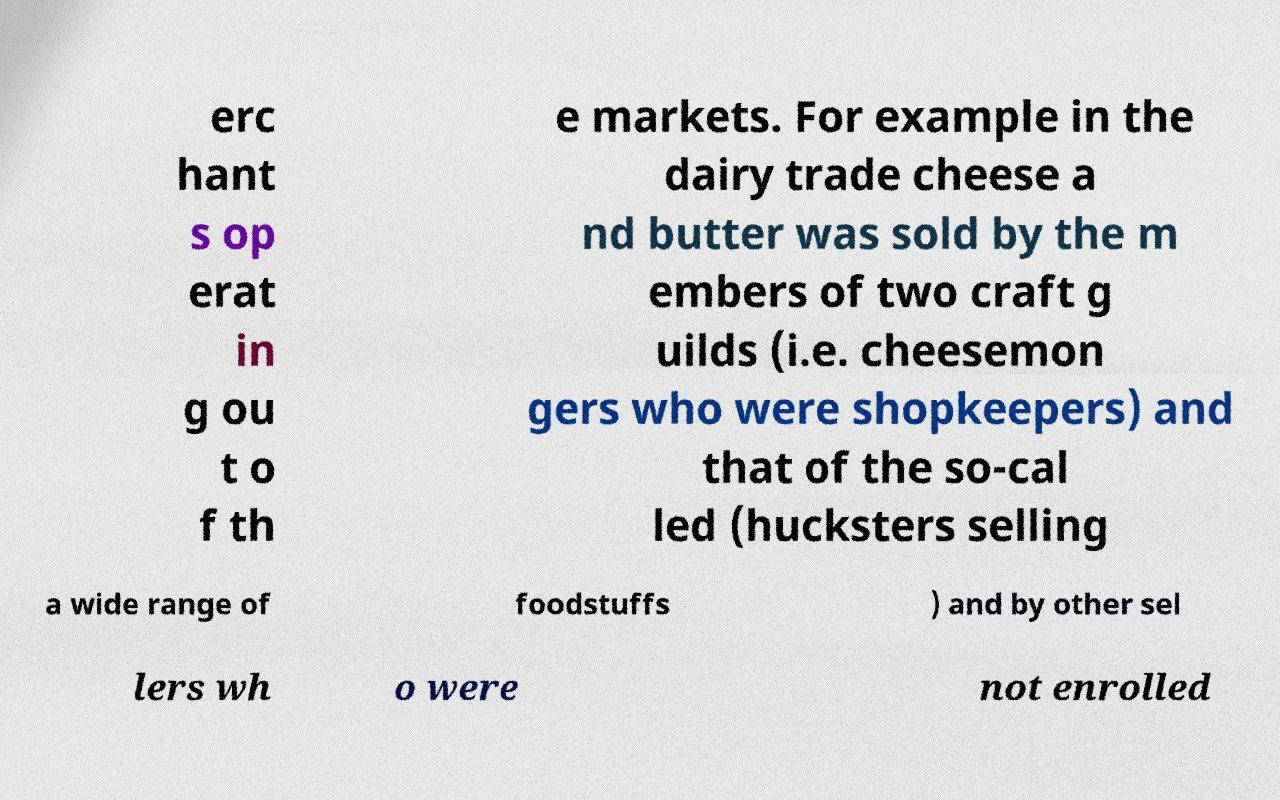Can you accurately transcribe the text from the provided image for me? erc hant s op erat in g ou t o f th e markets. For example in the dairy trade cheese a nd butter was sold by the m embers of two craft g uilds (i.e. cheesemon gers who were shopkeepers) and that of the so-cal led (hucksters selling a wide range of foodstuffs ) and by other sel lers wh o were not enrolled 